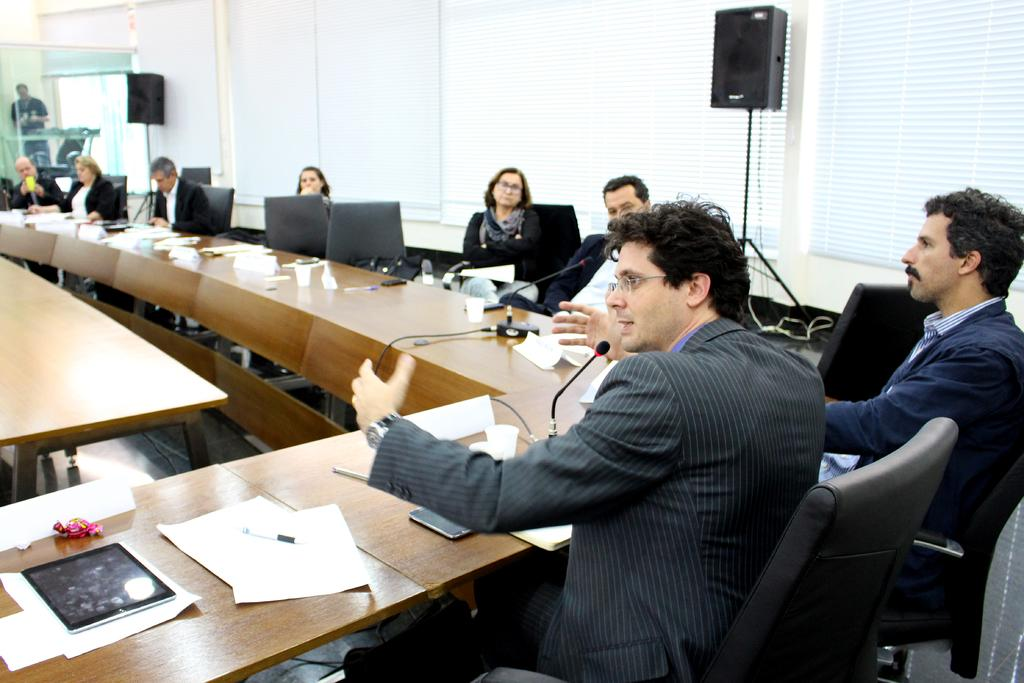What type of room is depicted in the image? There is a meeting room in the image. What are the people in the meeting room doing? The people are sitting on chairs in the meeting room. What items can be seen in the meeting room? There are papers and a sound box in the meeting room. What type of relation does the distribution of hall have with the image? There is no mention of a hall or distribution in the image, so it is not possible to determine any relation between them. 